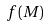Convert formula to latex. <formula><loc_0><loc_0><loc_500><loc_500>f ( M )</formula> 